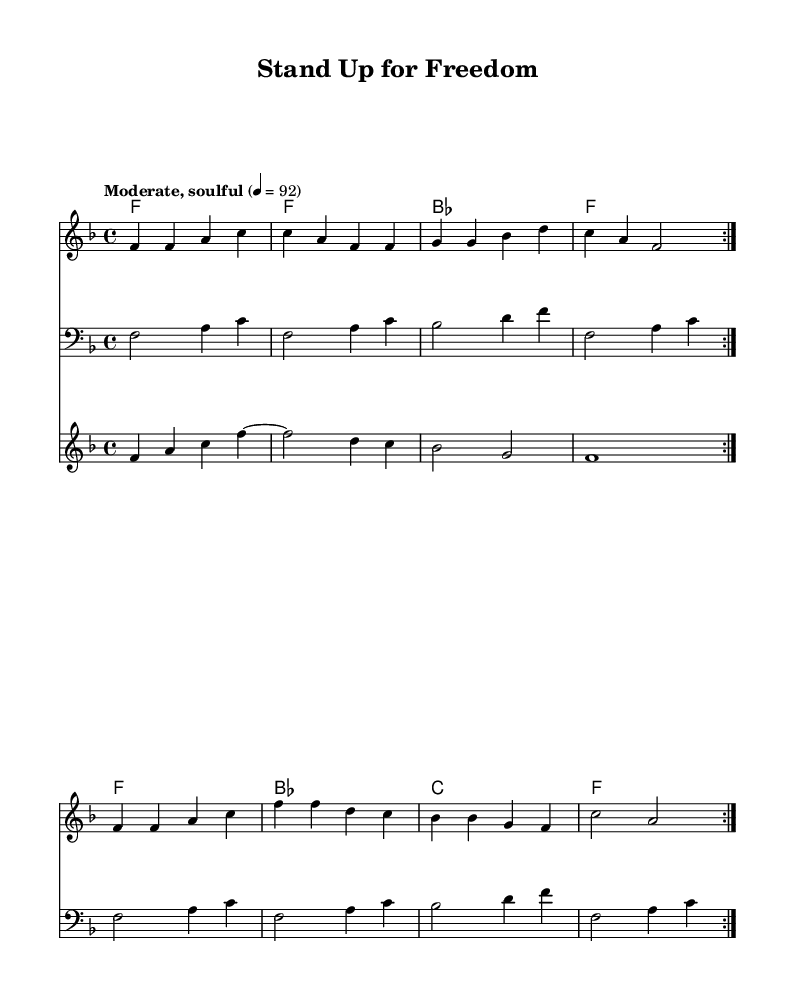What is the key signature of this music? The key signature is F major, which has one flat (B flat). This is indicated at the beginning of the music staff.
Answer: F major What is the time signature of this music? The time signature is 4/4, indicated right after the key signature. This means there are four beats in a measure, and the quarter note gets one beat.
Answer: 4/4 What is the tempo marking of this piece? The tempo marking is "Moderate, soulful," which is clearly stated at the beginning of the score, indicating the desired character and speed of the piece.
Answer: Moderate, soulful How many measures are in the repeated sections? There are 8 measures in total as indicated by the repetition marks and the musical notation within those repeated sections. Each repetition consists of 4 measures and is repeated twice.
Answer: 8 What is the main theme of the lyrics in the chorus? The main theme of the chorus emphasizes standing up for freedom and rights, reflecting the core message of unity and strength in the fight for social justice, as expressed in the words.
Answer: Freedom and rights What instruments are included in this arrangement? The arrangement includes a melody staff, a bass staff, a horns staff, and chord names, indicating the instruments or sections involved in the performance.
Answer: Melody, bass, horns What structure does the song use in its lyrics? The song structure alternates between verses and a chorus, which is a common form in soul music, allowing for storytelling followed by repeating the central message.
Answer: Verse-Chorus 